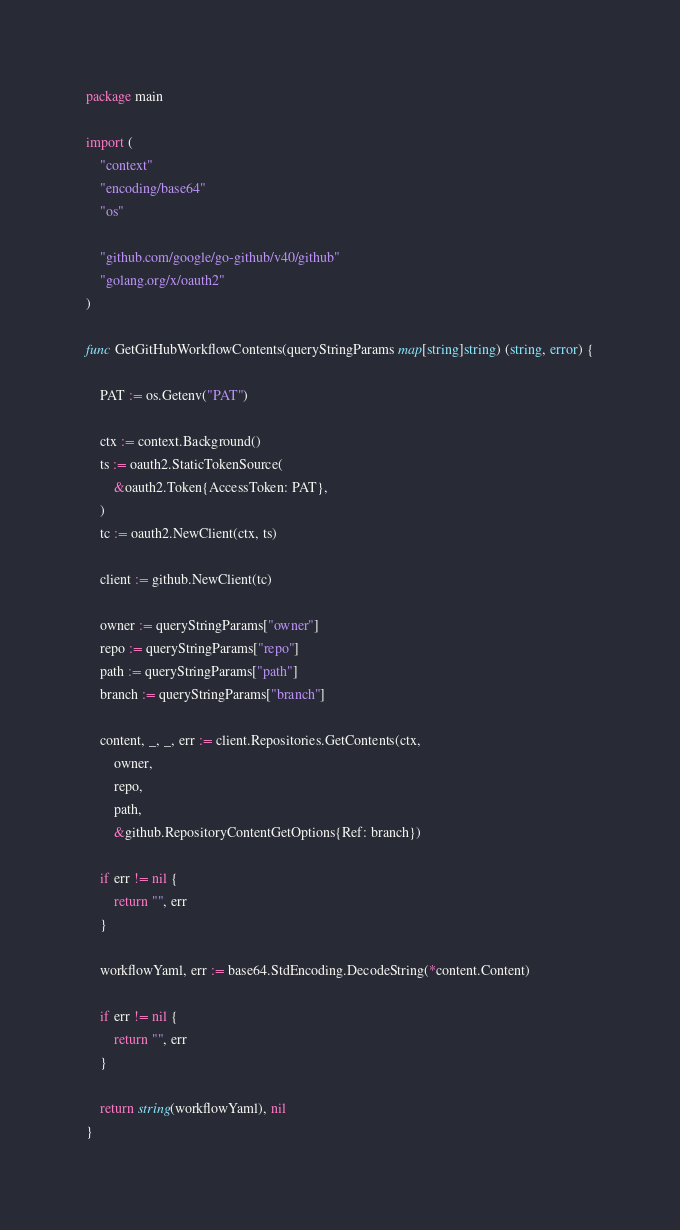<code> <loc_0><loc_0><loc_500><loc_500><_Go_>package main

import (
	"context"
	"encoding/base64"
	"os"

	"github.com/google/go-github/v40/github"
	"golang.org/x/oauth2"
)

func GetGitHubWorkflowContents(queryStringParams map[string]string) (string, error) {

	PAT := os.Getenv("PAT")

	ctx := context.Background()
	ts := oauth2.StaticTokenSource(
		&oauth2.Token{AccessToken: PAT},
	)
	tc := oauth2.NewClient(ctx, ts)

	client := github.NewClient(tc)

	owner := queryStringParams["owner"]
	repo := queryStringParams["repo"]
	path := queryStringParams["path"]
	branch := queryStringParams["branch"]

	content, _, _, err := client.Repositories.GetContents(ctx,
		owner,
		repo,
		path,
		&github.RepositoryContentGetOptions{Ref: branch})

	if err != nil {
		return "", err
	}

	workflowYaml, err := base64.StdEncoding.DecodeString(*content.Content)

	if err != nil {
		return "", err
	}

	return string(workflowYaml), nil
}
</code> 